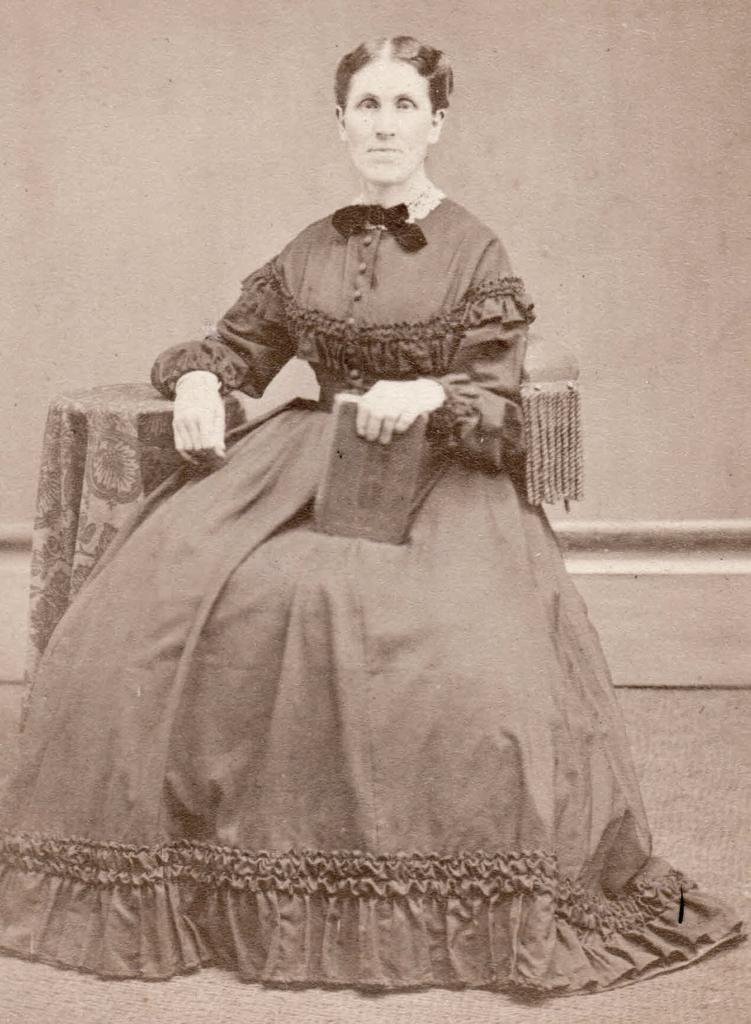What is the woman in the image doing? The woman is sitting in the image. What is the woman holding in her hand? The woman is holding an object in her hand. What can be seen in the background of the image? There is a wall in the background of the image. What type of spring can be seen in the image? There is no spring present in the image. Is there an arch visible in the image? There is no arch visible in the image. 